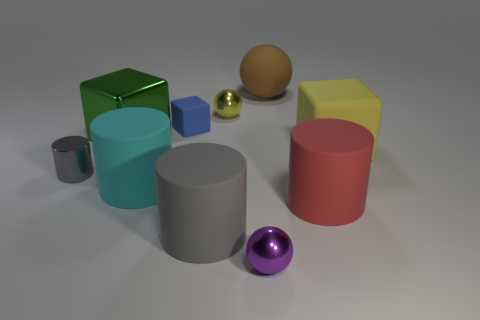Subtract all big matte cylinders. How many cylinders are left? 1 Subtract 1 cubes. How many cubes are left? 2 Subtract all blue cylinders. Subtract all gray cubes. How many cylinders are left? 4 Subtract all cylinders. How many objects are left? 6 Add 4 big yellow blocks. How many big yellow blocks exist? 5 Subtract 0 red balls. How many objects are left? 10 Subtract all big gray metal balls. Subtract all big yellow matte blocks. How many objects are left? 9 Add 8 blue objects. How many blue objects are left? 9 